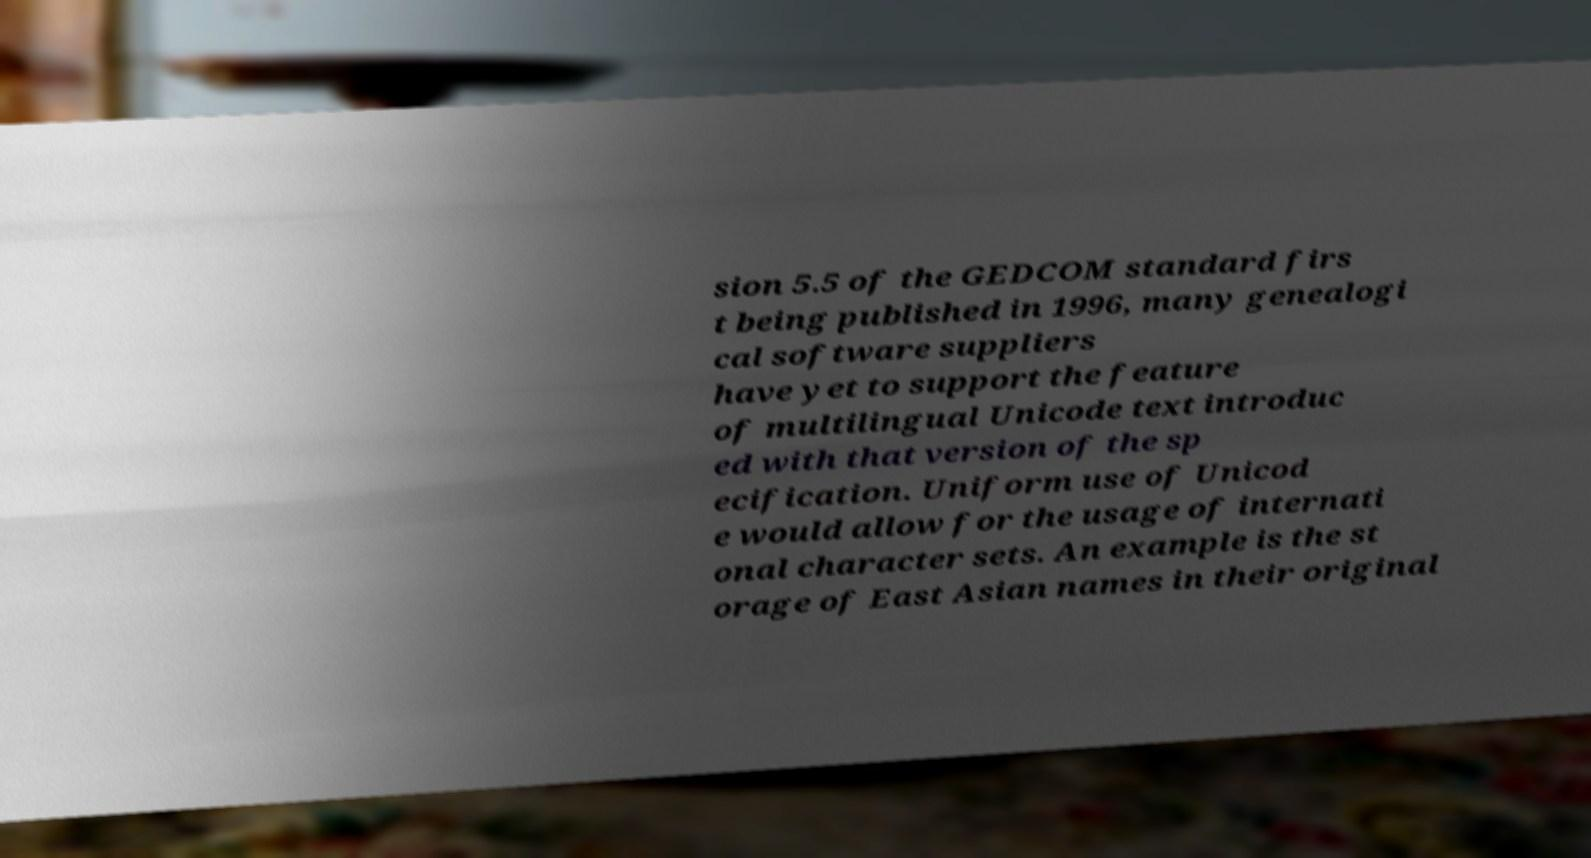Can you read and provide the text displayed in the image?This photo seems to have some interesting text. Can you extract and type it out for me? sion 5.5 of the GEDCOM standard firs t being published in 1996, many genealogi cal software suppliers have yet to support the feature of multilingual Unicode text introduc ed with that version of the sp ecification. Uniform use of Unicod e would allow for the usage of internati onal character sets. An example is the st orage of East Asian names in their original 